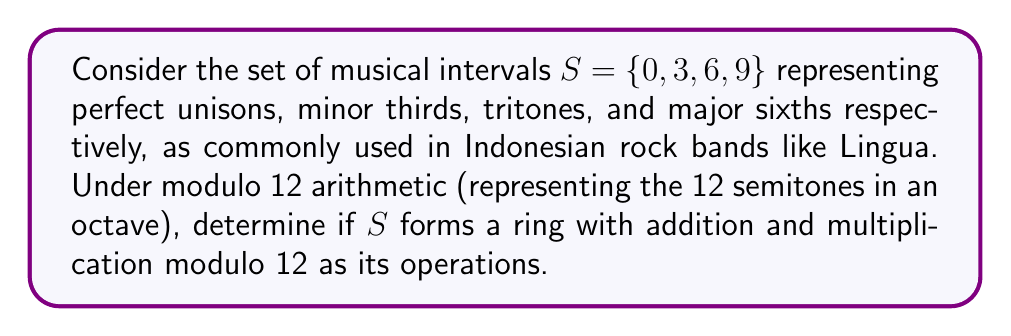Can you solve this math problem? To determine if $S$ forms a ring under modulo 12 arithmetic, we need to check if it satisfies the following properties:

1. $(S, +)$ is an abelian group:
   a) Closure: For all $a, b \in S$, $a + b \bmod 12 \in S$
   b) Associativity: $(a + b) + c = a + (b + c)$ for all $a, b, c \in S$
   c) Commutativity: $a + b = b + a$ for all $a, b \in S$
   d) Identity: There exists $0 \in S$ such that $a + 0 = a$ for all $a \in S$
   e) Inverse: For each $a \in S$, there exists $-a \in S$ such that $a + (-a) = 0$

2. $(S, \cdot)$ is a monoid:
   a) Closure: For all $a, b \in S$, $a \cdot b \bmod 12 \in S$
   b) Associativity: $(a \cdot b) \cdot c = a \cdot (b \cdot c)$ for all $a, b, c \in S$
   c) Identity: There exists $1 \in S$ such that $a \cdot 1 = a$ for all $a \in S$

3. Distributivity: $a \cdot (b + c) = (a \cdot b) + (a \cdot c)$ for all $a, b, c \in S$

Let's check each property:

1. $(S, +)$:
   a) Closure: 
      $0 + 3 = 3$, $0 + 6 = 6$, $0 + 9 = 9$
      $3 + 3 = 6$, $3 + 6 = 9$, $3 + 9 = 0$
      $6 + 3 = 9$, $6 + 6 = 0$, $6 + 9 = 3$
      $9 + 3 = 0$, $9 + 6 = 3$, $9 + 9 = 6$
      All results are in $S$, so closure holds.
   b) Associativity: Holds for modular arithmetic.
   c) Commutativity: Holds for modular arithmetic.
   d) Identity: $0 \in S$ is the identity element.
   e) Inverse: $0 + 0 = 0$, $3 + 9 = 0$, $6 + 6 = 0$, $9 + 3 = 0$
      Each element has an inverse in $S$.

2. $(S, \cdot)$:
   a) Closure:
      $0 \cdot 3 = 0$, $0 \cdot 6 = 0$, $0 \cdot 9 = 0$
      $3 \cdot 3 = 9$, $3 \cdot 6 = 6$, $3 \cdot 9 = 3$
      $6 \cdot 3 = 6$, $6 \cdot 6 = 0$, $6 \cdot 9 = 6$
      $9 \cdot 3 = 3$, $9 \cdot 6 = 6$, $9 \cdot 9 = 9$
      All results are in $S$, so closure holds.
   b) Associativity: Holds for modular arithmetic.
   c) Identity: There is no multiplicative identity in $S$ (1 is not in $S$).

3. Distributivity: Holds for modular arithmetic.

Since $(S, \cdot)$ does not have an identity element, $S$ does not form a ring under modulo 12 arithmetic.
Answer: No, $S = \{0, 3, 6, 9\}$ does not form a ring under modulo 12 arithmetic because it lacks a multiplicative identity element. 